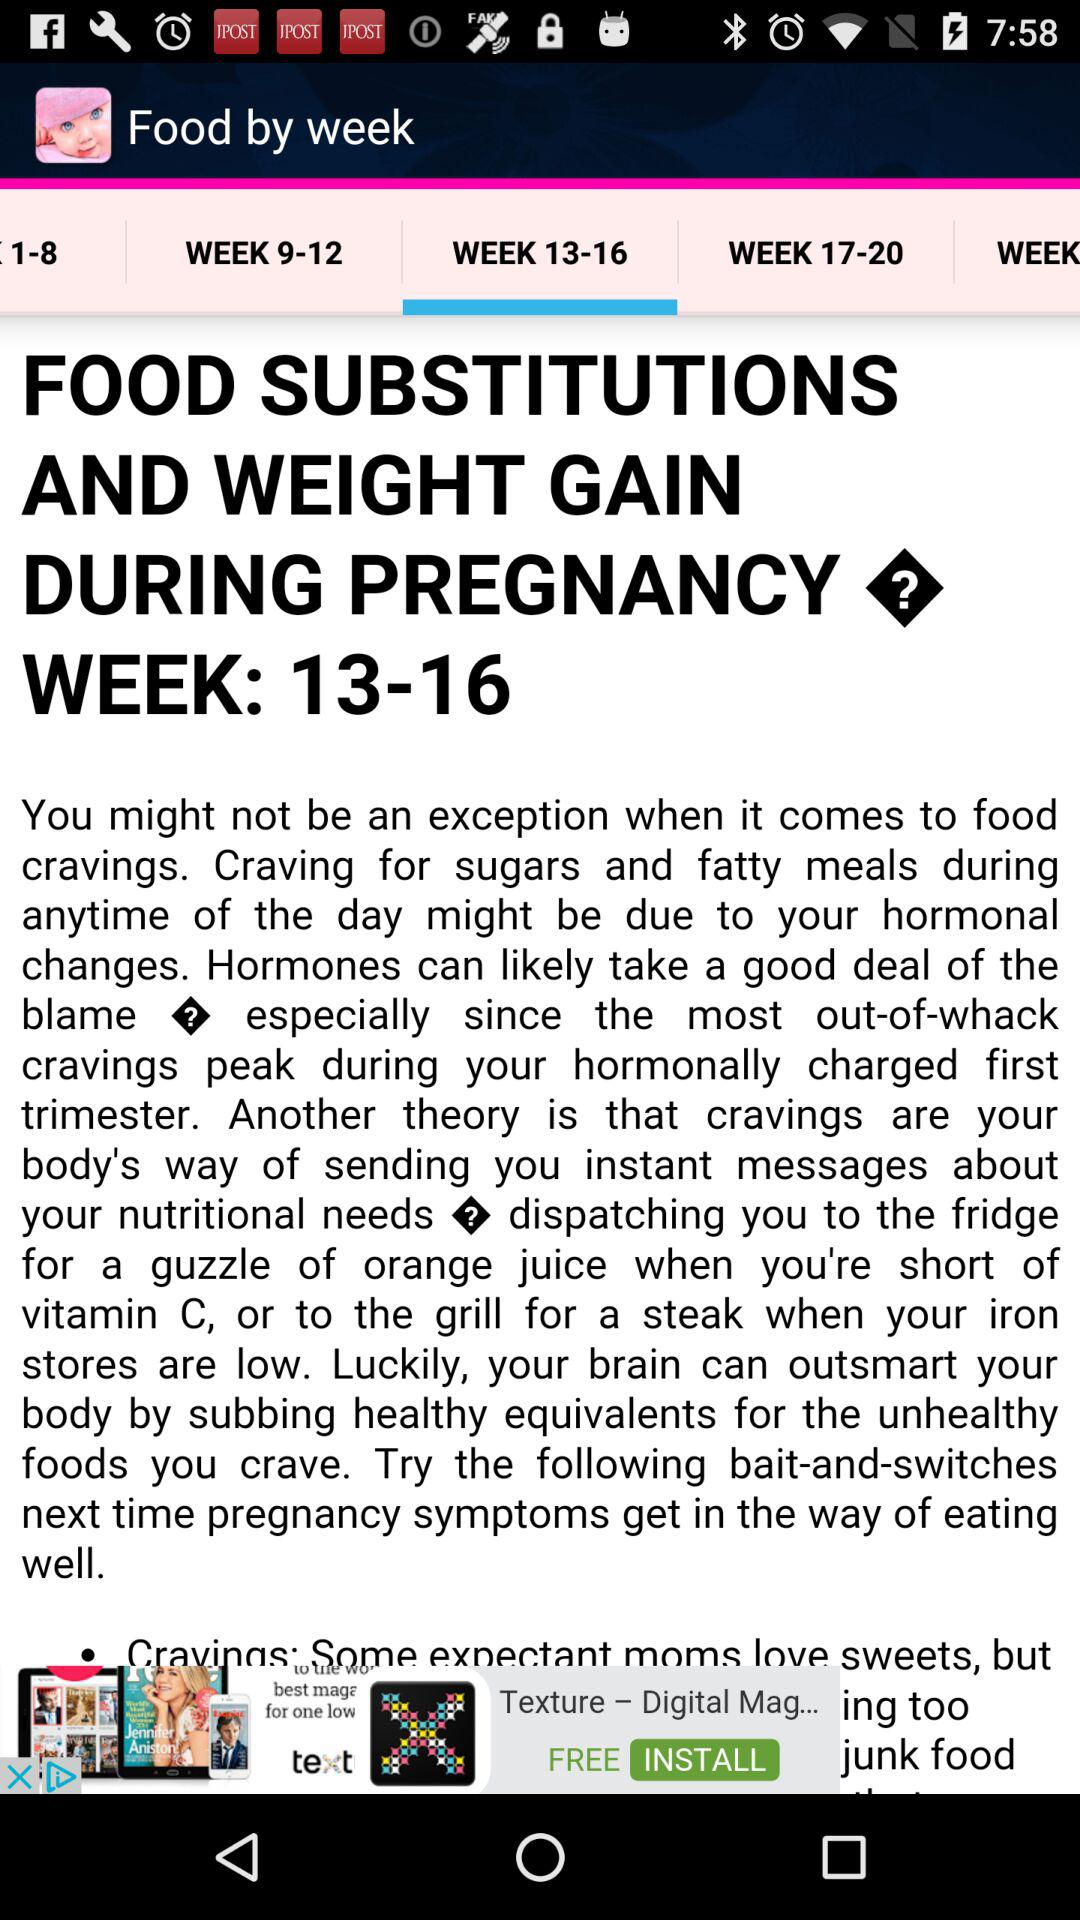What is the name of the application? The name of the application is "Food by week". 